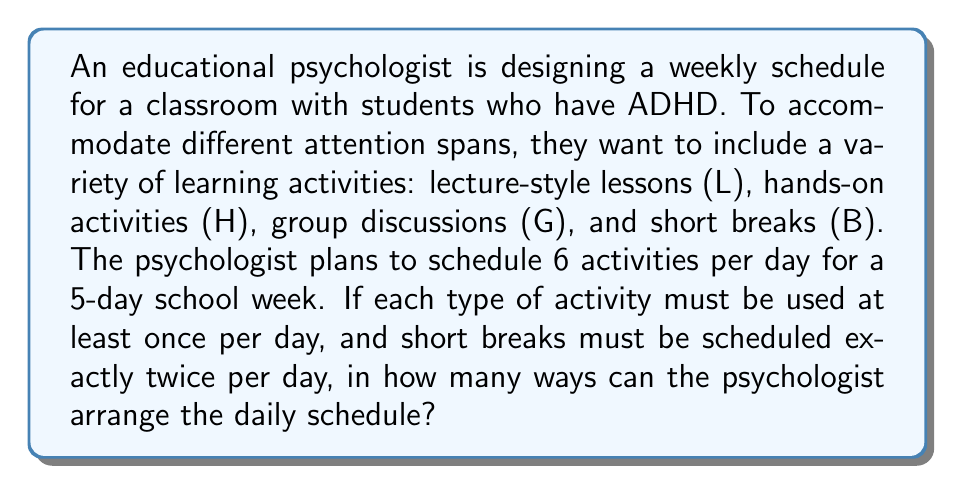Teach me how to tackle this problem. Let's approach this step-by-step:

1) We need to schedule 6 activities per day.

2) We know that short breaks (B) must be scheduled exactly twice per day, leaving 4 slots for other activities.

3) Among these 4 remaining slots, we must include at least one of each: L, H, and G.

4) This means we have 3 fixed positions (L, H, G) and 1 flexible position that can be filled by either L, H, or G.

5) We can represent this as a combination problem. We need to choose positions for:
   - 2 breaks (B) out of 6 slots
   - 1 flexible activity (L, H, or G) out of the remaining 4 slots

6) For the breaks:
   $$\binom{6}{2} = \frac{6!}{2!(6-2)!} = \frac{6 \cdot 5}{2 \cdot 1} = 15$$

7) For the flexible activity, we have 3 choices (L, H, or G) and 4 possible positions:
   $$3 \cdot 4 = 12$$

8) By the multiplication principle, the total number of ways to arrange one day's schedule is:
   $$15 \cdot 12 = 180$$

9) Since this arrangement is repeated for each of the 5 days in the school week, and each day can be arranged independently, we apply the multiplication principle again:
   $$180^5 = 1,889,568,000,000$$

Therefore, there are 1,889,568,000,000 ways to arrange the weekly schedule.
Answer: 1,889,568,000,000 ways 